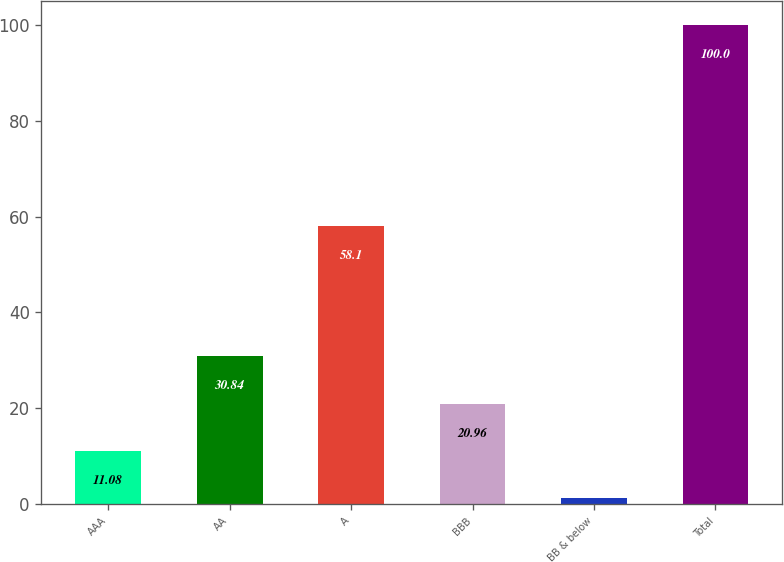Convert chart. <chart><loc_0><loc_0><loc_500><loc_500><bar_chart><fcel>AAA<fcel>AA<fcel>A<fcel>BBB<fcel>BB & below<fcel>Total<nl><fcel>11.08<fcel>30.84<fcel>58.1<fcel>20.96<fcel>1.2<fcel>100<nl></chart> 